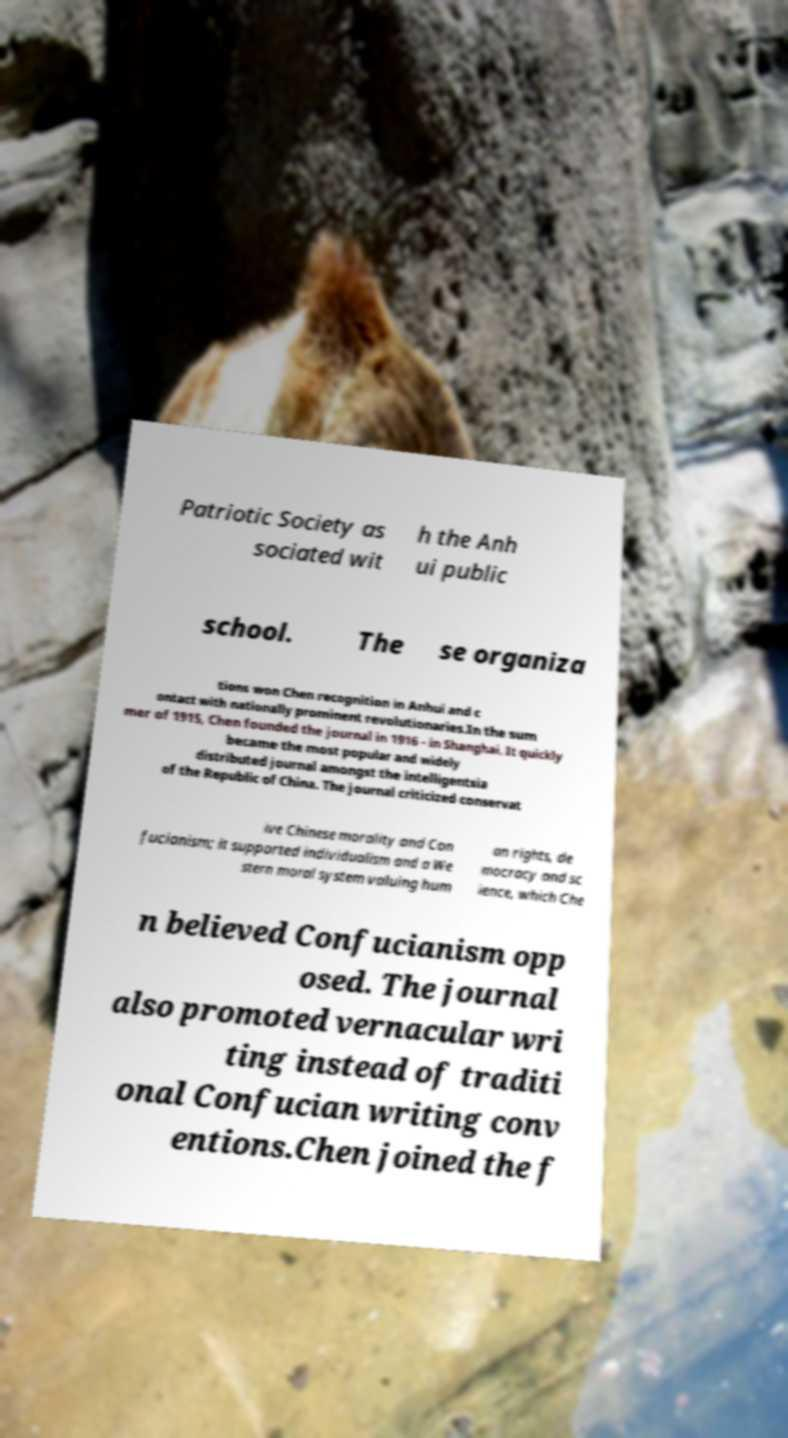For documentation purposes, I need the text within this image transcribed. Could you provide that? Patriotic Society as sociated wit h the Anh ui public school. The se organiza tions won Chen recognition in Anhui and c ontact with nationally prominent revolutionaries.In the sum mer of 1915, Chen founded the journal in 1916 - in Shanghai. It quickly became the most popular and widely distributed journal amongst the intelligentsia of the Republic of China. The journal criticized conservat ive Chinese morality and Con fucianism; it supported individualism and a We stern moral system valuing hum an rights, de mocracy and sc ience, which Che n believed Confucianism opp osed. The journal also promoted vernacular wri ting instead of traditi onal Confucian writing conv entions.Chen joined the f 